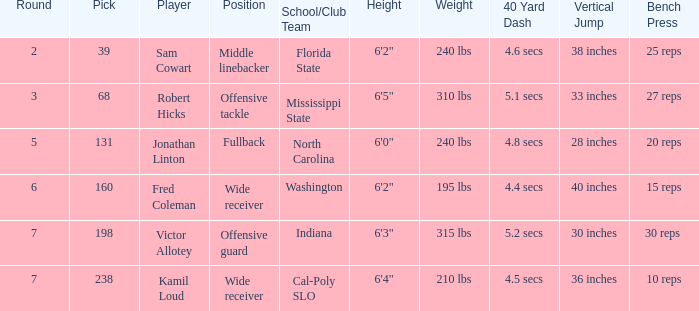Which Round has a School/Club Team of cal-poly slo, and a Pick smaller than 238? None. 